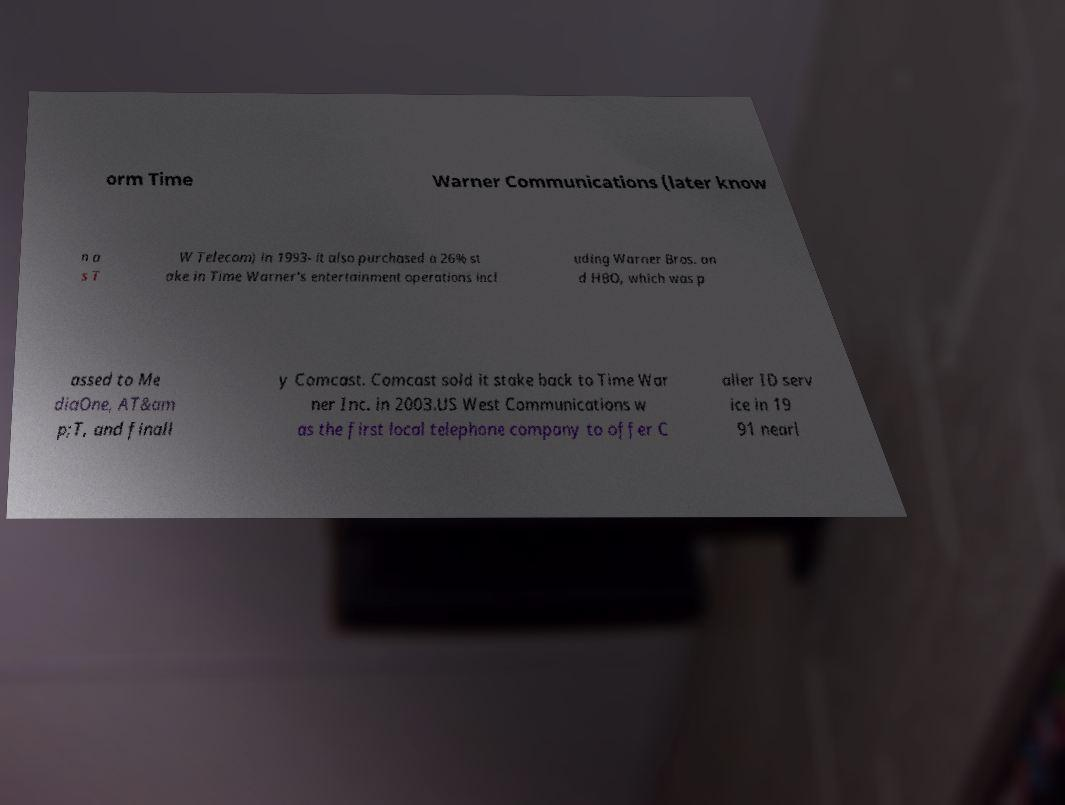Could you extract and type out the text from this image? orm Time Warner Communications (later know n a s T W Telecom) in 1993- it also purchased a 26% st ake in Time Warner's entertainment operations incl uding Warner Bros. an d HBO, which was p assed to Me diaOne, AT&am p;T, and finall y Comcast. Comcast sold it stake back to Time War ner Inc. in 2003.US West Communications w as the first local telephone company to offer C aller ID serv ice in 19 91 nearl 